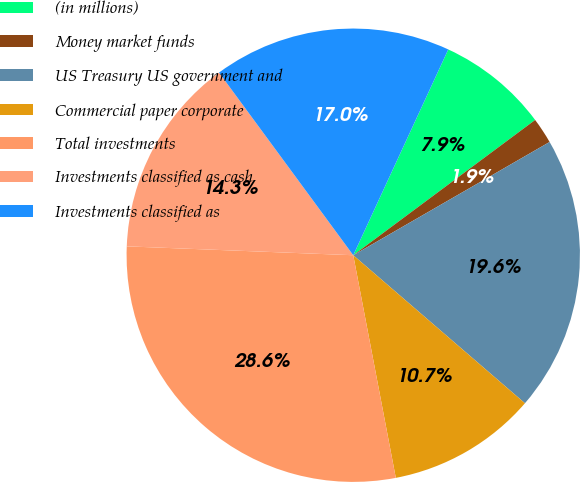Convert chart. <chart><loc_0><loc_0><loc_500><loc_500><pie_chart><fcel>(in millions)<fcel>Money market funds<fcel>US Treasury US government and<fcel>Commercial paper corporate<fcel>Total investments<fcel>Investments classified as cash<fcel>Investments classified as<nl><fcel>7.94%<fcel>1.85%<fcel>19.65%<fcel>10.67%<fcel>28.63%<fcel>14.29%<fcel>16.97%<nl></chart> 